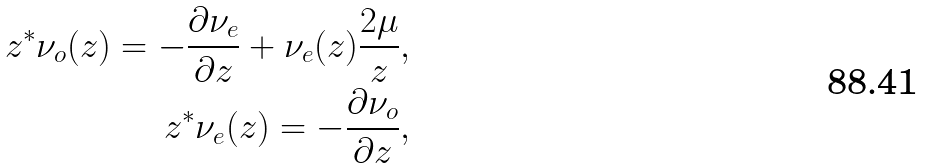Convert formula to latex. <formula><loc_0><loc_0><loc_500><loc_500>z ^ { * } \nu _ { o } ( z ) = - \frac { \partial \nu _ { e } } { \partial z } + \nu _ { e } ( z ) \frac { 2 \mu } { z } , \\ z ^ { * } \nu _ { e } ( z ) = - \frac { \partial \nu _ { o } } { \partial z } ,</formula> 